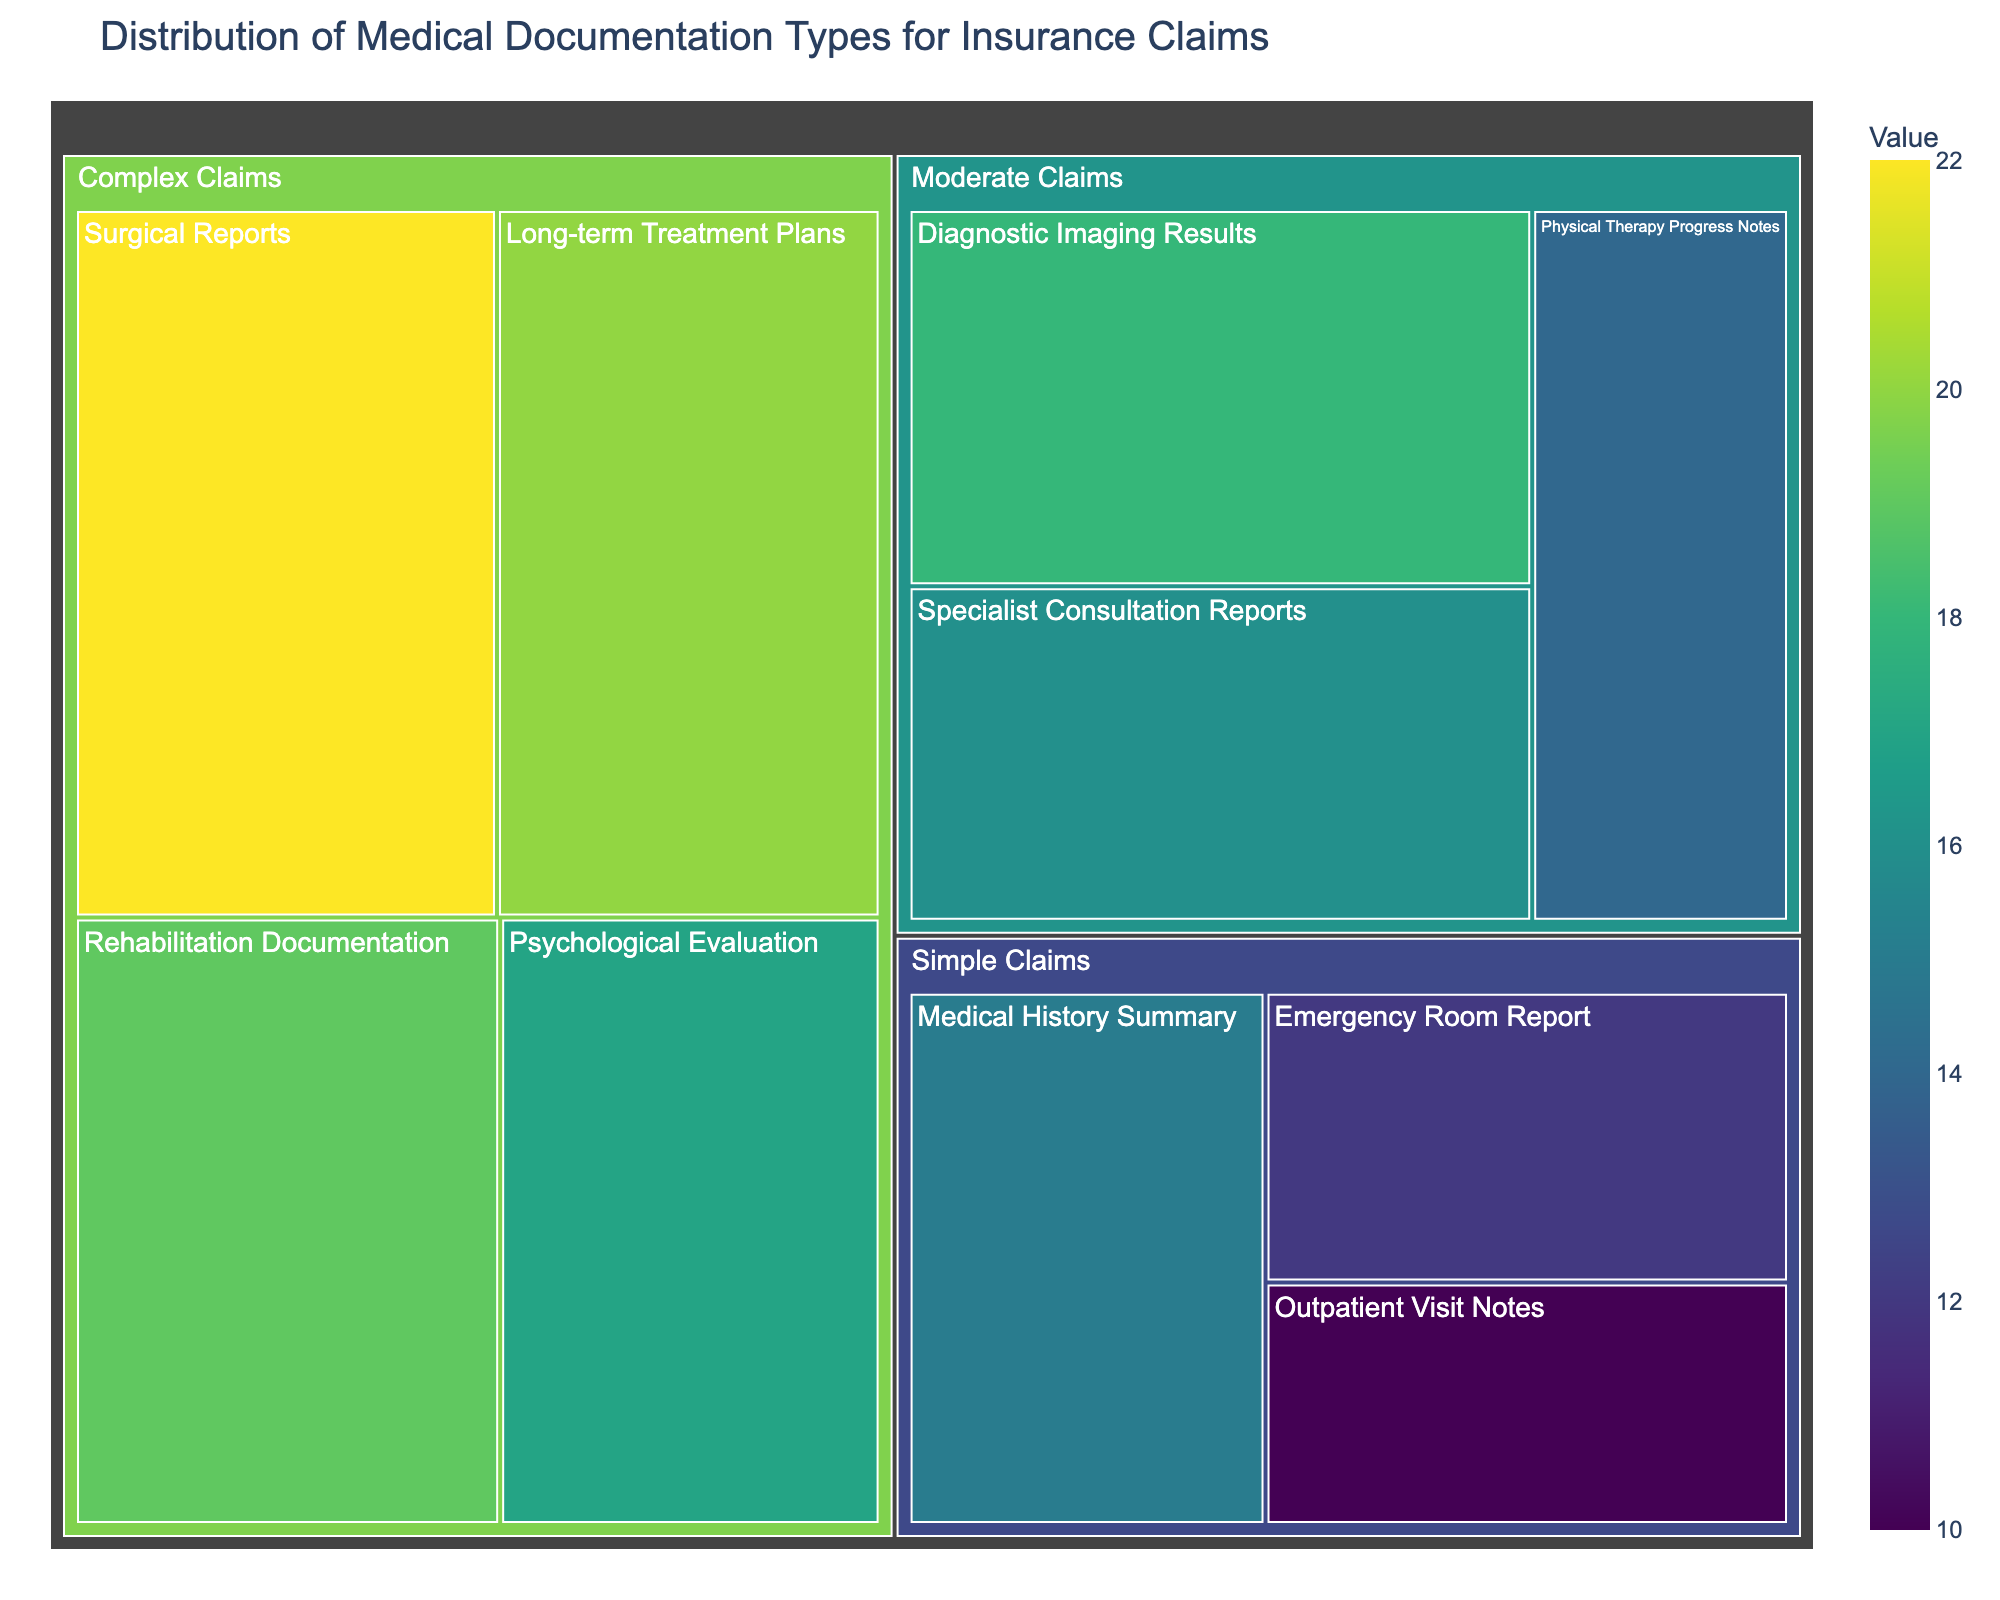What is the title of the Treemap? The title of the Treemap is usually located at the top of the chart. By examining this area, we can find the given title.
Answer: Distribution of Medical Documentation Types for Insurance Claims Which subcategory within "Simple Claims" has the highest value? By inspecting the Treemap within the "Simple Claims" category, we identify the subcategory with the largest block or higher color intensity.
Answer: Medical History Summary What is the total sum of values for "Moderate Claims"? Sum up the values of each subcategory within "Moderate Claims": Diagnostic Imaging Results (18) + Specialist Consultation Reports (16) + Physical Therapy Progress Notes (14). The total sum is 48.
Answer: 48 How do the values of "Surgical Reports" compare to "Outpatient Visit Notes"? "Surgical Reports" is a subcategory under "Complex Claims" and "Outpatient Visit Notes" is under "Simple Claims". By comparing the values, Surgical Reports (22) has a higher value than Outpatient Visit Notes (10).
Answer: Surgical Reports > Outpatient Visit Notes Which category contains the subcategory with the lowest value overall? The lowest value is found by looking at each subcategory across all categories. "Simple Claims" contains "Outpatient Visit Notes" with a value of 10, which is the lowest overall value.
Answer: Simple Claims What is the difference between the value of "Long-term Treatment Plans" and "Emergency Room Report"? Find the values of each subcategory: Long-term Treatment Plans (20) and Emergency Room Report (12). The difference is 20 - 12 = 8.
Answer: 8 How many subcategories are there in total across all categories? Count the number of subcategories listed across "Simple Claims", "Moderate Claims", and "Complex Claims": There are 3 in Simple Claims, 3 in Moderate Claims, and 4 in Complex Claims. Adding them together, we get 3 + 3 + 4 = 10 subcategories.
Answer: 10 Which subcategory has the highest value in "Complex Claims"? By examining the subcategories within "Complex Claims", we identify the one with the largest block or highest color intensity. "Surgical Reports" has the value of 22, which is the highest.
Answer: Surgical Reports What is the combined value of all subcategories under "Complex Claims"? Adding the values of each subcategory within "Complex Claims": Surgical Reports (22) + Long-term Treatment Plans (20) + Psychological Evaluation (17) + Rehabilitation Documentation (19). The total sum is 22 + 20 + 17 + 19 = 78.
Answer: 78 